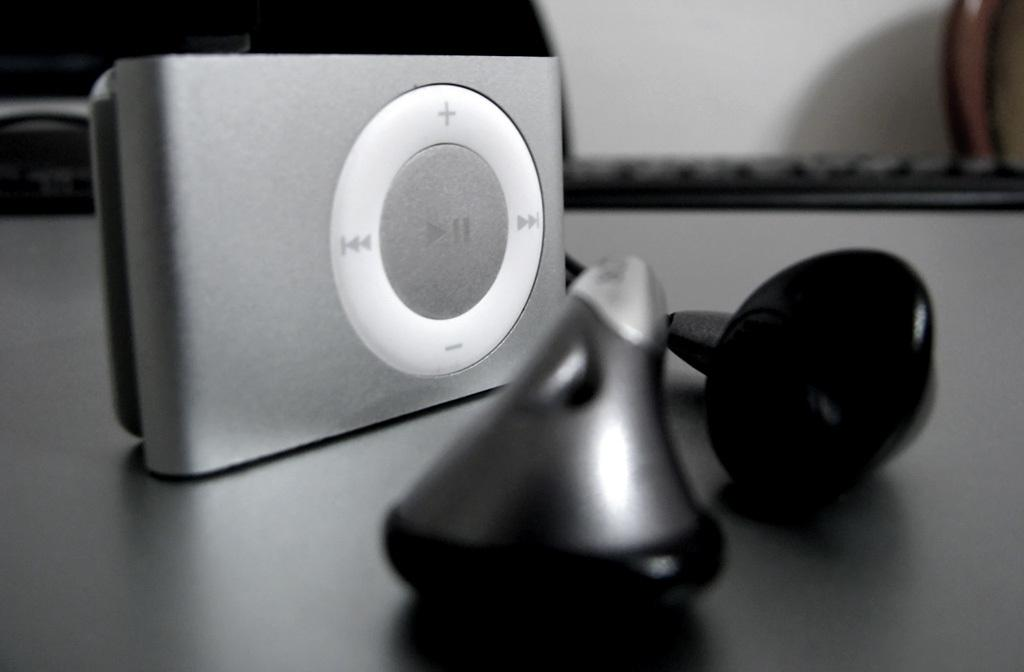What piece of furniture is in the image? There is a desk in the image. What electronic device is on the desk? An iPod is present on the desk. What accessory is with the iPod? Headsets are visible with the iPod. What is located behind the desk? There is a keyboard behind the desk. Where is the stick used by the tiger on the stage in the image? There is no stick, tiger, or stage present in the image. 